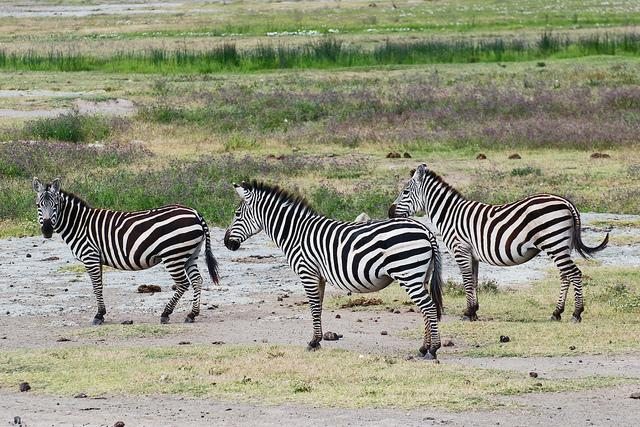What word shares the same first letter as the name of these animals?

Choices:
A) carrot
B) zipper
C) baby
D) deep zipper 